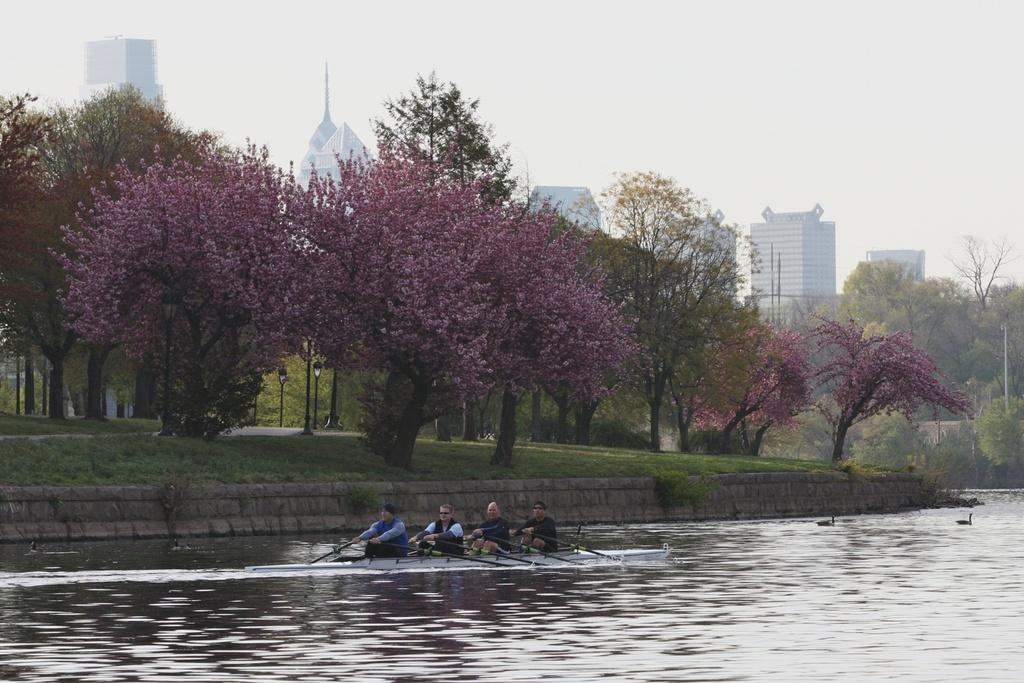What are the people in the image doing? The people in the image are riding a boat. Where is the boat located? The boat is on the water. What can be seen in the background of the image? There are trees, light poles, buildings, and the sky visible in the image. How many feet are visible in the image? There are no feet visible in the image; it features people riding a boat on the water. What type of reward is being given to the people in the image? There is no reward being given to the people in the image; they are simply riding a boat. 